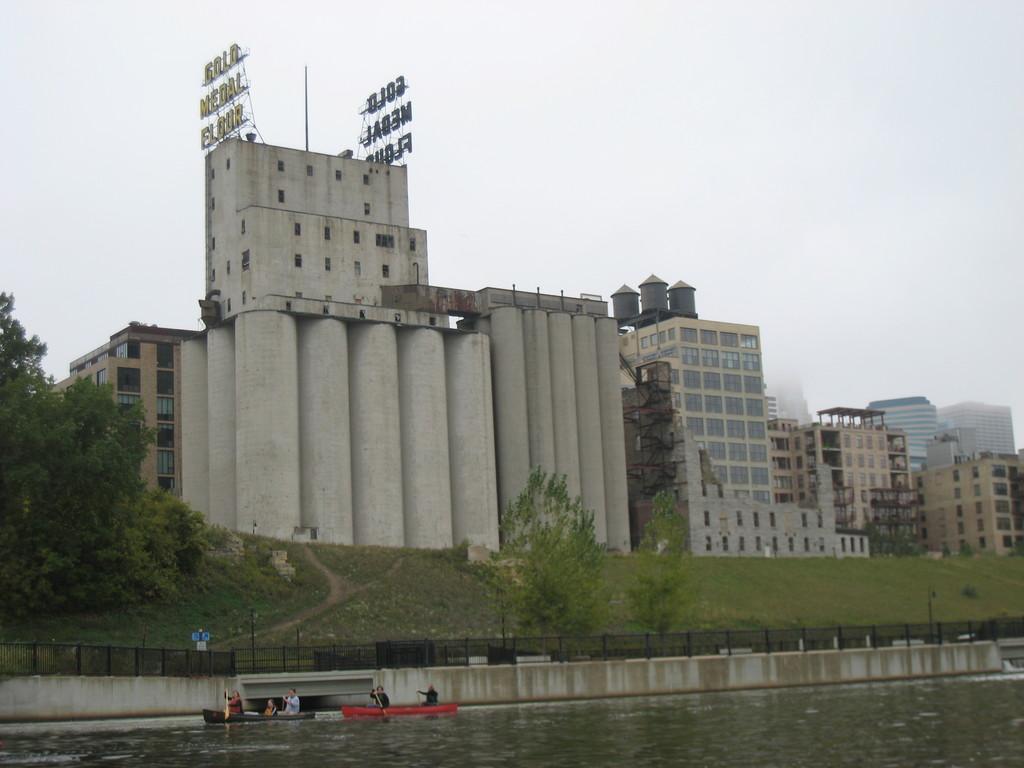Could you give a brief overview of what you see in this image? In this image I can see the boats on the water. I can see few people in the boats. In the background I can see the railing, many trees and the buildings. I can also see the sky in the back. 